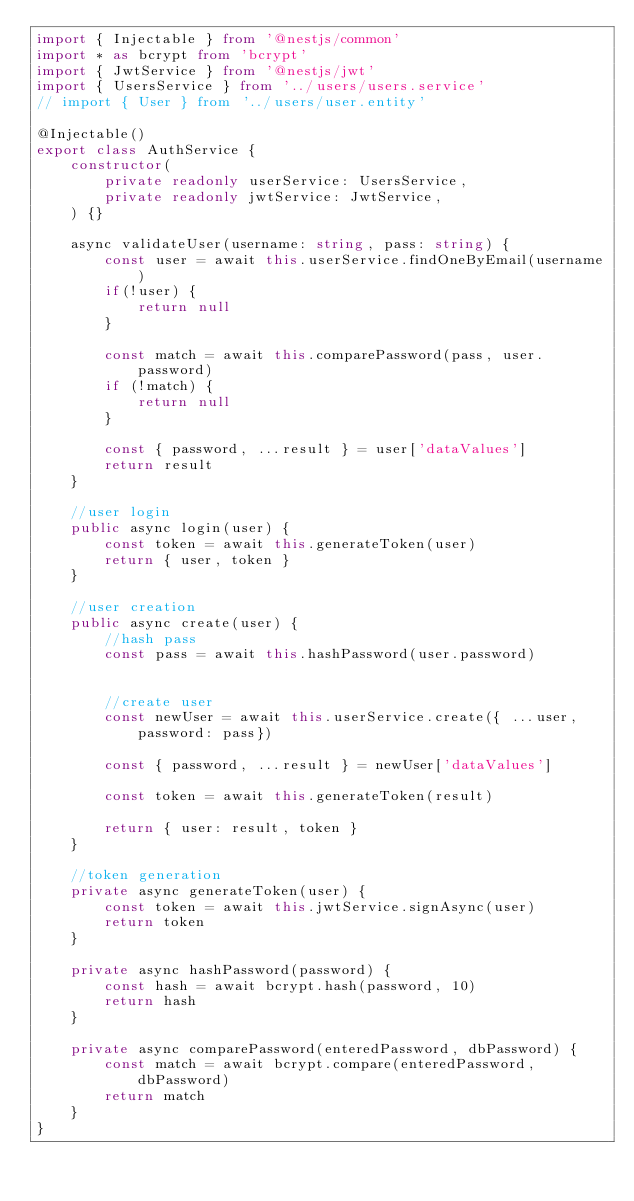<code> <loc_0><loc_0><loc_500><loc_500><_TypeScript_>import { Injectable } from '@nestjs/common'
import * as bcrypt from 'bcrypt'
import { JwtService } from '@nestjs/jwt'
import { UsersService } from '../users/users.service'
// import { User } from '../users/user.entity'

@Injectable()
export class AuthService {
    constructor(
        private readonly userService: UsersService,
        private readonly jwtService: JwtService,
    ) {}

    async validateUser(username: string, pass: string) {
        const user = await this.userService.findOneByEmail(username)
        if(!user) {
            return null
        }

        const match = await this.comparePassword(pass, user.password)
        if (!match) {
            return null
        }

        const { password, ...result } = user['dataValues']
        return result
    }

    //user login
    public async login(user) {
        const token = await this.generateToken(user)
        return { user, token }
    }

    //user creation
    public async create(user) {
        //hash pass
        const pass = await this.hashPassword(user.password)
    

        //create user
        const newUser = await this.userService.create({ ...user, password: pass})

        const { password, ...result } = newUser['dataValues']

        const token = await this.generateToken(result)

        return { user: result, token }
    }

    //token generation
    private async generateToken(user) {
        const token = await this.jwtService.signAsync(user)
        return token
    }

    private async hashPassword(password) {
        const hash = await bcrypt.hash(password, 10)
        return hash
    }

    private async comparePassword(enteredPassword, dbPassword) {
        const match = await bcrypt.compare(enteredPassword, dbPassword)
        return match
    }
}</code> 